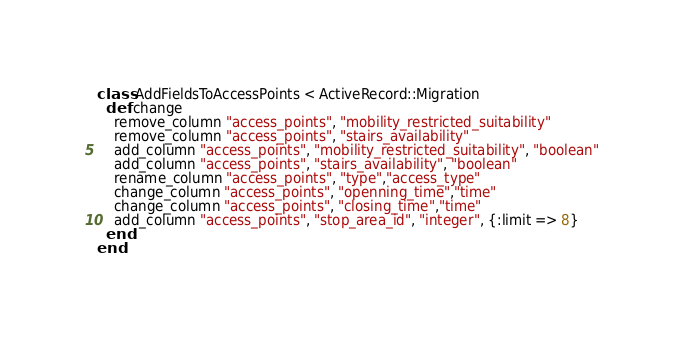Convert code to text. <code><loc_0><loc_0><loc_500><loc_500><_Ruby_>class AddFieldsToAccessPoints < ActiveRecord::Migration
  def change
    remove_column "access_points", "mobility_restricted_suitability"
    remove_column "access_points", "stairs_availability"
    add_column "access_points", "mobility_restricted_suitability", "boolean"
    add_column "access_points", "stairs_availability", "boolean"
    rename_column "access_points", "type","access_type"
    change_column "access_points", "openning_time","time"
    change_column "access_points", "closing_time","time"
    add_column "access_points", "stop_area_id", "integer", {:limit => 8}
  end
end
</code> 